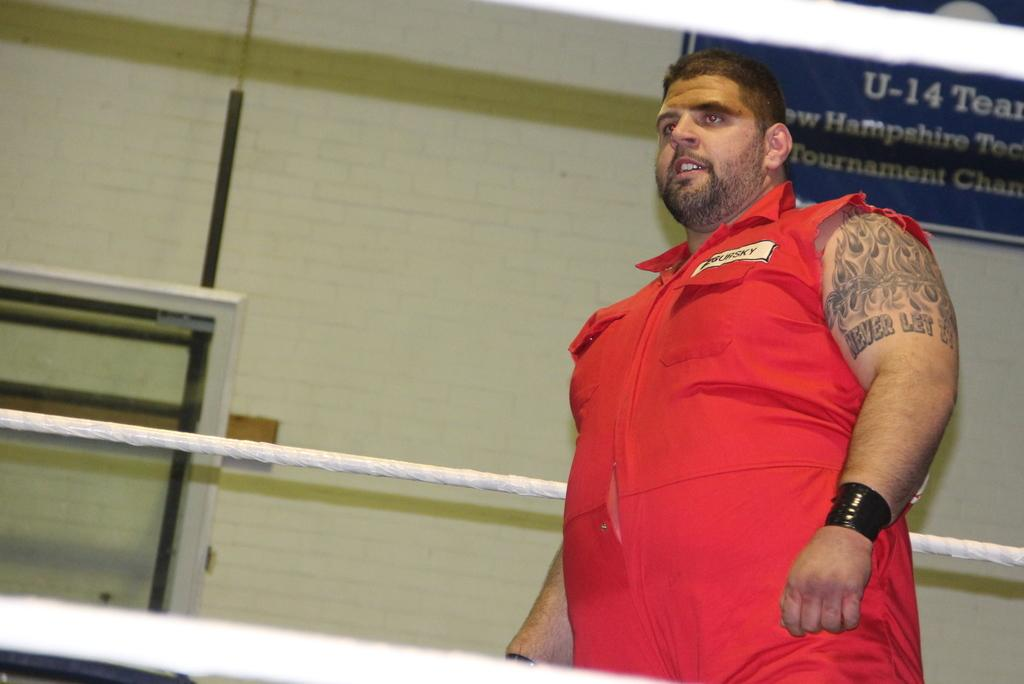<image>
Relay a brief, clear account of the picture shown. A man wearing a sleeveless red outfit has a tattoo that says, "Never Let It". 